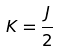Convert formula to latex. <formula><loc_0><loc_0><loc_500><loc_500>K = \frac { J } { 2 }</formula> 